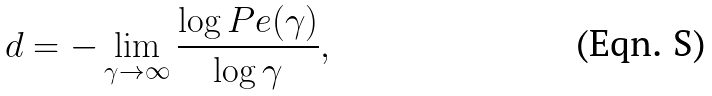<formula> <loc_0><loc_0><loc_500><loc_500>d = - \lim _ { \gamma \rightarrow \infty } \frac { \log P e ( \gamma ) } { \log \gamma } ,</formula> 